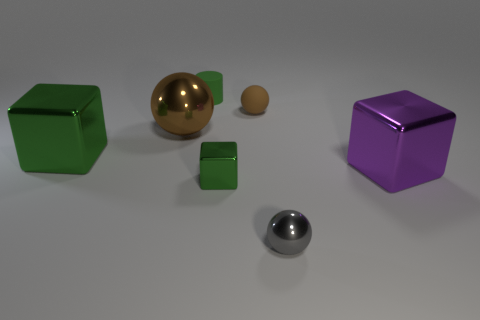Is there anything else that is the same size as the gray thing?
Provide a succinct answer. Yes. There is a rubber cylinder; are there any green metal blocks to the left of it?
Offer a very short reply. Yes. What shape is the big brown metal thing?
Your answer should be compact. Sphere. How many things are large green metal objects to the left of the brown metal ball or metallic cubes?
Make the answer very short. 3. How many other things are the same color as the small matte cylinder?
Provide a short and direct response. 2. Does the big metal ball have the same color as the sphere that is in front of the brown shiny object?
Your answer should be very brief. No. What color is the other large object that is the same shape as the large green object?
Offer a terse response. Purple. Are the tiny green cylinder and the tiny ball in front of the big purple metal object made of the same material?
Make the answer very short. No. What is the color of the tiny metal block?
Offer a very short reply. Green. There is a matte object right of the tiny shiny object that is to the left of the metallic sphere that is to the right of the tiny brown thing; what is its color?
Your response must be concise. Brown. 